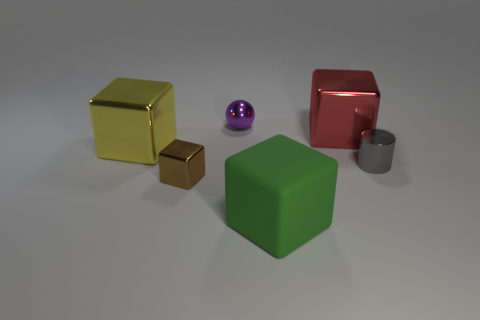Can you infer the function of these objects, or are they purely decorative? With the information provided in the image, these objects appear to be decorative with no evident functional use. They might serve as a study in shapes, colors, and materials, or be part of an artistic display or a 3D modeling practice setup. How would the atmosphere of the room change if the green cube was replaced with a blue one? Replacing the green cube with a blue one would alter the color dynamics of the scene, introducing a cooler tone that could evoke feelings of calm and serenity, changing the vibe of the room towards a more relaxed and possibly more professional setting. 